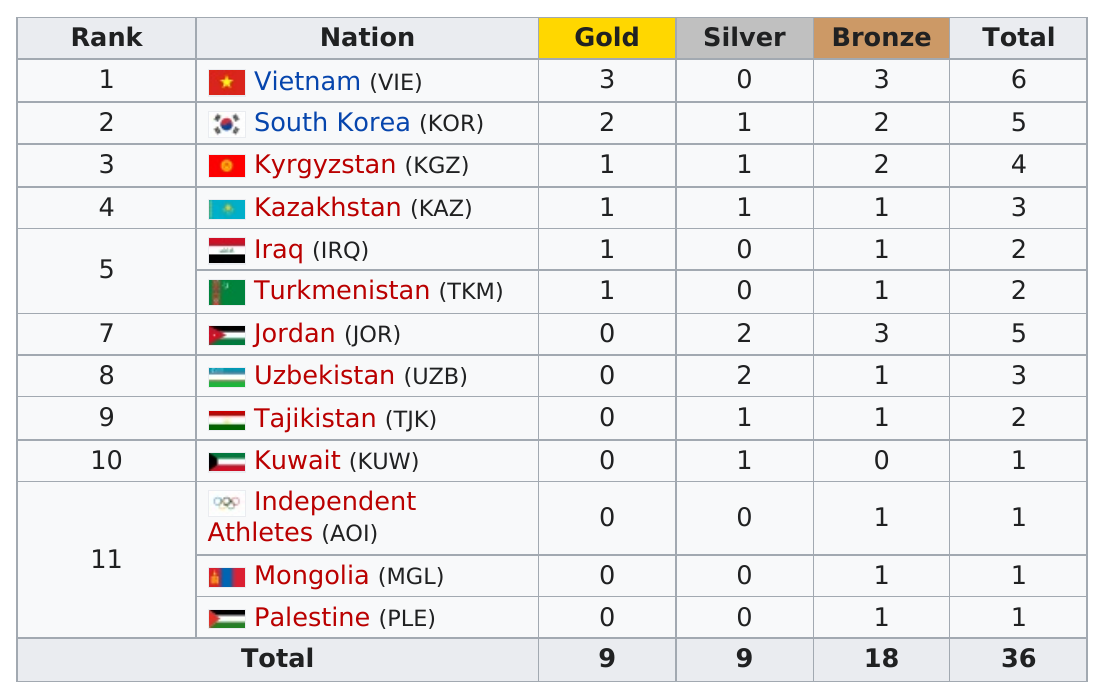Draw attention to some important aspects in this diagram. Vietnam won three gold medals during the 2013 competition. Iraq has won a total of two medals. The total medal count was 36. A total of 9 gold medals were won. South Korea, which is the nation next in line for the highest number of gold medals, is a prominent contender in the upcoming Olympic Games. 